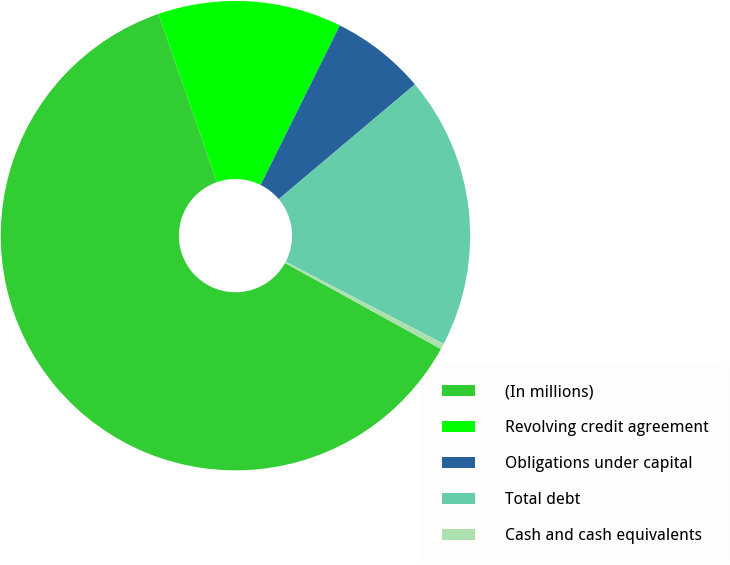Convert chart to OTSL. <chart><loc_0><loc_0><loc_500><loc_500><pie_chart><fcel>(In millions)<fcel>Revolving credit agreement<fcel>Obligations under capital<fcel>Total debt<fcel>Cash and cash equivalents<nl><fcel>61.65%<fcel>12.65%<fcel>6.52%<fcel>18.77%<fcel>0.4%<nl></chart> 